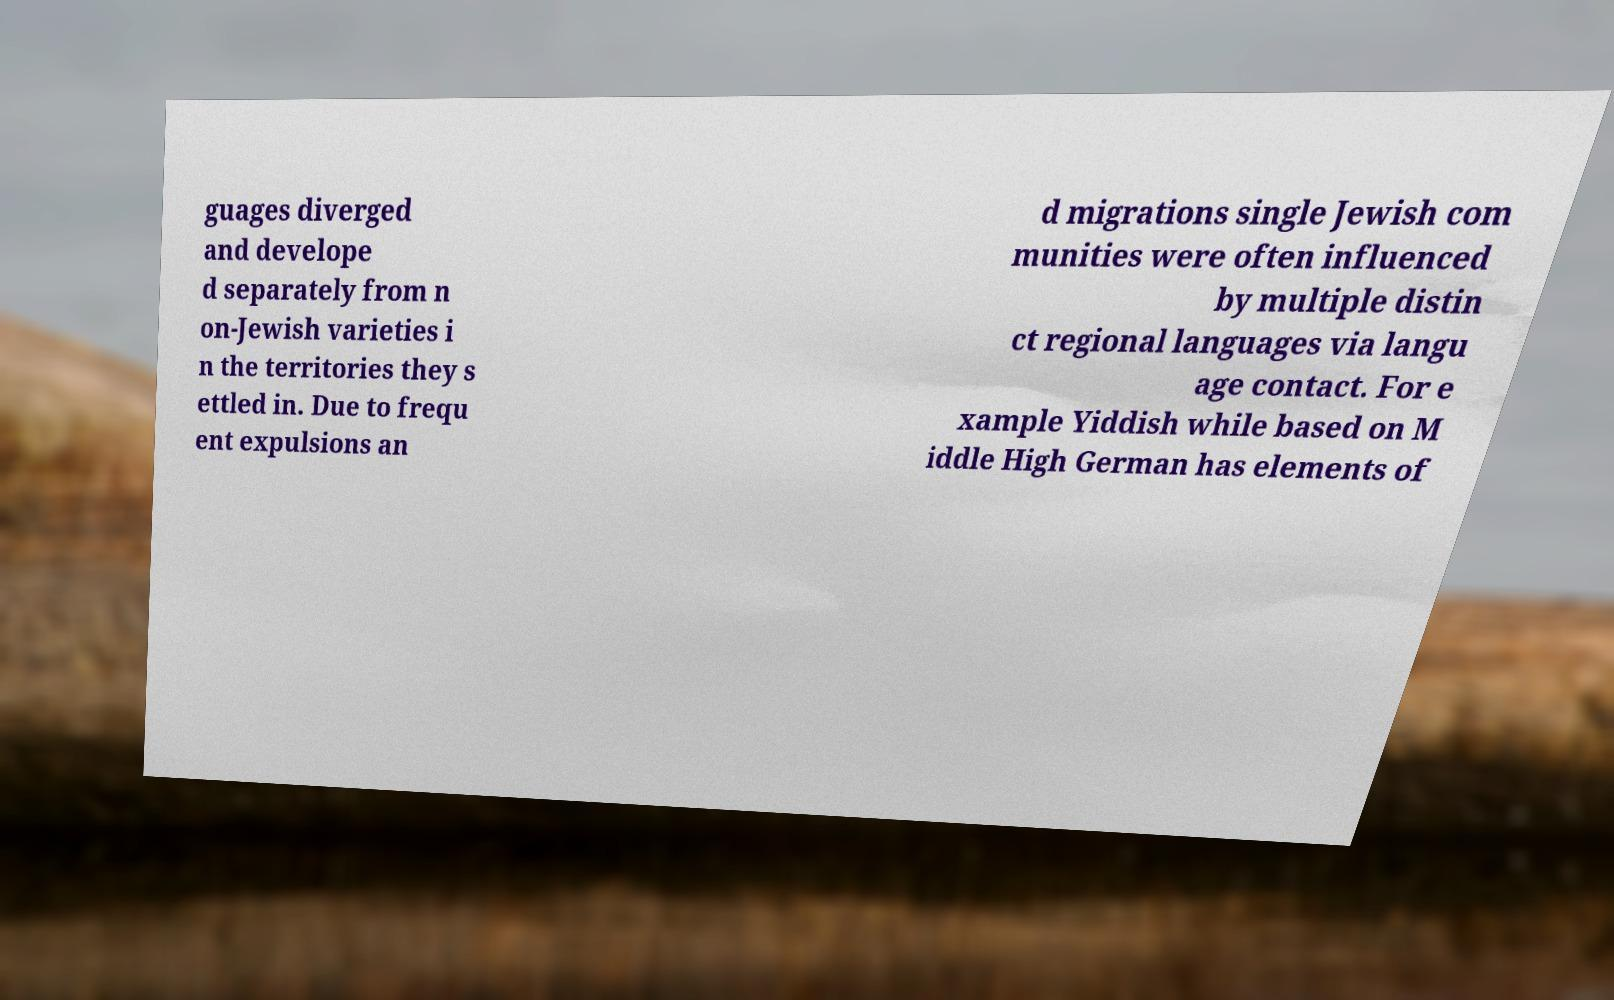I need the written content from this picture converted into text. Can you do that? guages diverged and develope d separately from n on-Jewish varieties i n the territories they s ettled in. Due to frequ ent expulsions an d migrations single Jewish com munities were often influenced by multiple distin ct regional languages via langu age contact. For e xample Yiddish while based on M iddle High German has elements of 